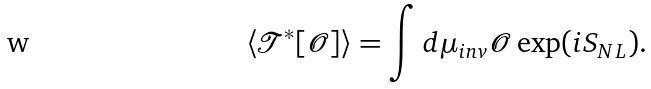Convert formula to latex. <formula><loc_0><loc_0><loc_500><loc_500>\langle \mathcal { T } ^ { * } [ \mathcal { O } ] \rangle = \int d \mu _ { i n v } \mathcal { O } \exp ( i S _ { N L } ) .</formula> 